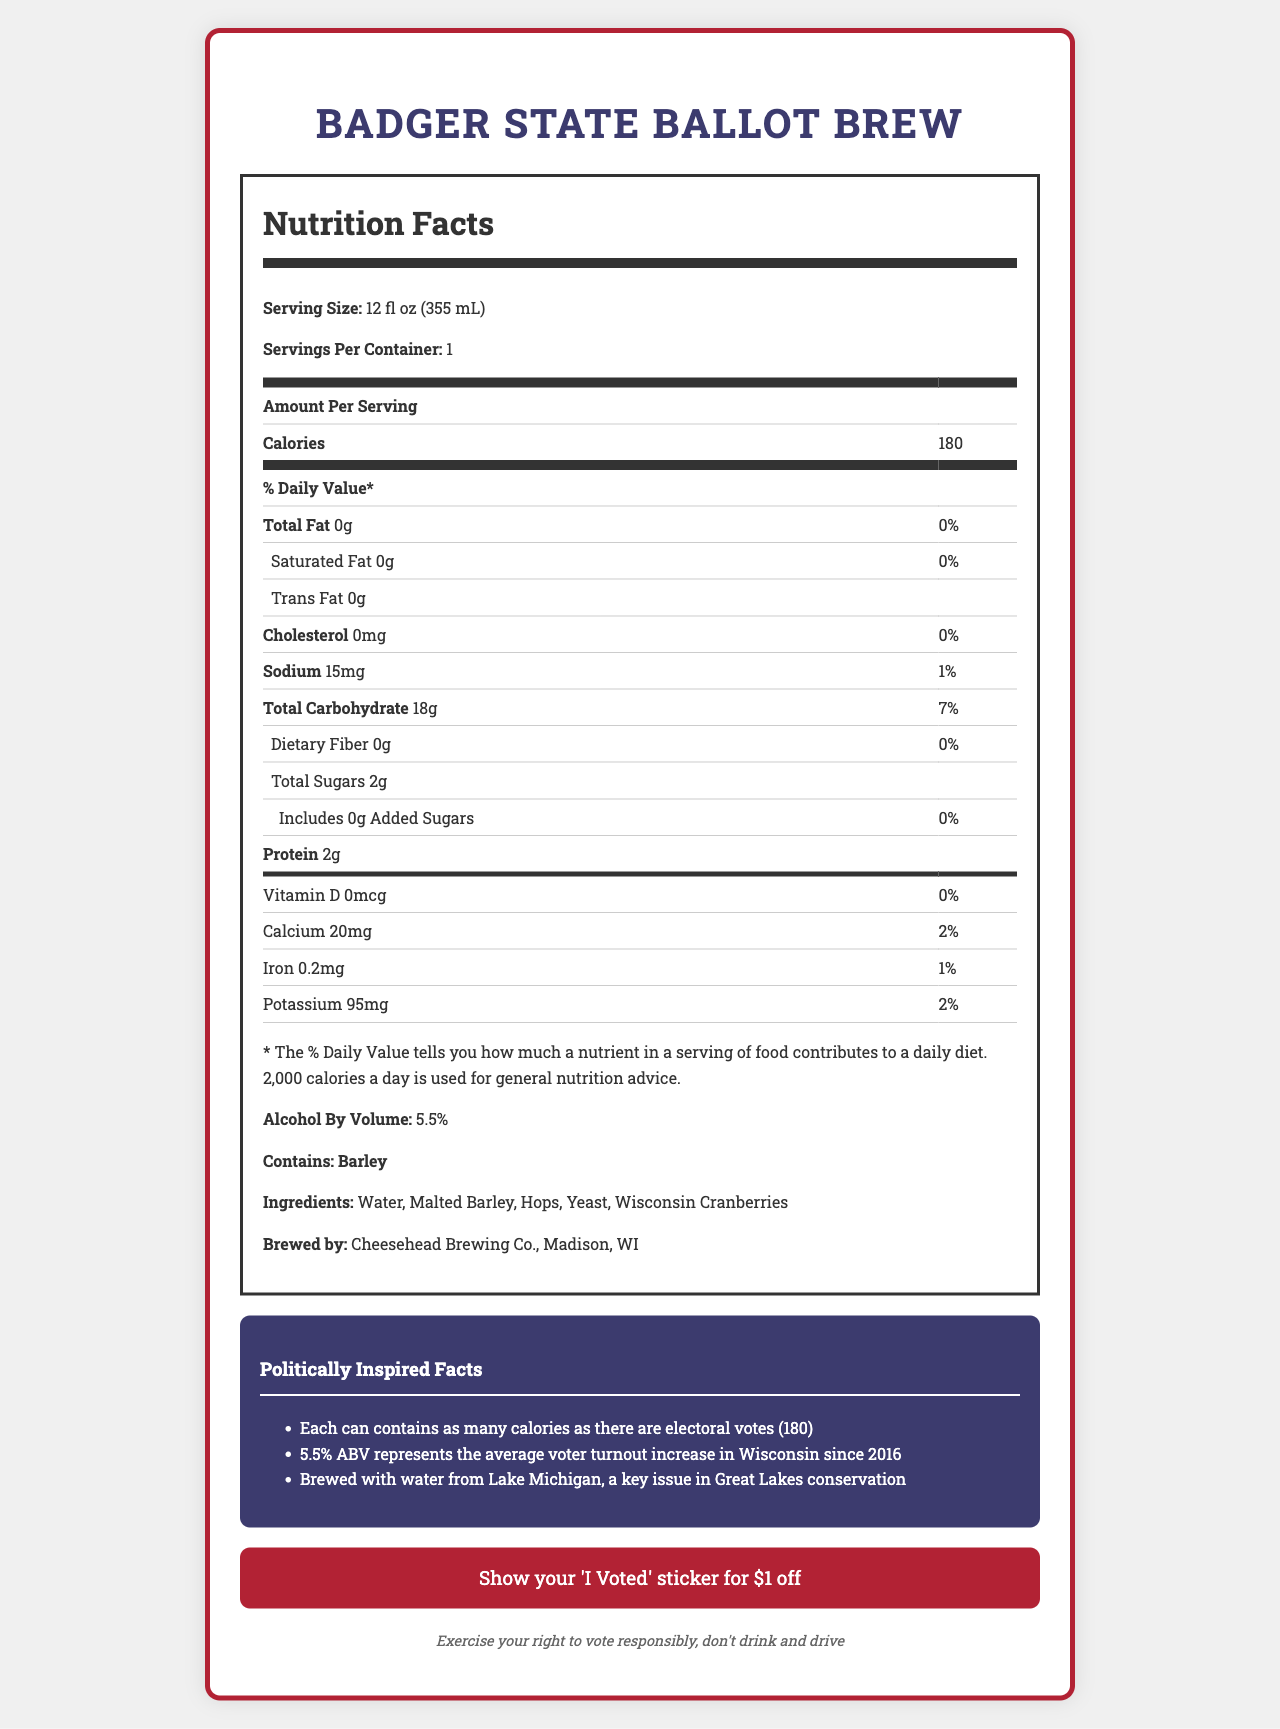what is the serving size of the Badger State Ballot Brew? The serving size is explicitly stated in the nutrition facts section of the document as "Serving Size: 12 fl oz (355 mL)".
Answer: 12 fl oz (355 mL) how many calories are in one serving of the Badger State Ballot Brew? The number of calories per serving is clearly listed as "Calories: 180" in the nutrition facts.
Answer: 180 what is the alcohol by volume (ABV) percentage? The alcohol content is specified in the nutrition facts section as "Alcohol By Volume: 5.5%".
Answer: 5.5% which allergen does the Badger State Ballot Brew contain? The allergen information is particularly shown under the allergens section as "Contains: Barley".
Answer: Barley name three ingredients included in the Badger State Ballot Brew? The ingredient list in the nutrition facts section includes "Water, Malted Barley, Hops, Yeast, Wisconsin Cranberries".
Answer: Water, Malted Barley, Hops what brewery produces the Badger State Ballot Brew? The brewery information is given toward the bottom of the document as "Brewed by: Cheesehead Brewing Co., Madison, WI".
Answer: Cheesehead Brewing Co. what promo is available for election night? The promotional information states: "Show your 'I Voted' sticker for $1 off".
Answer: Show your 'I Voted' sticker for $1 off how is the number of calories connected to the election? One of the politically inspired facts mentioned is that the number of calories corresponds to the number of electoral votes, which is indicated next to the calorie count.
Answer: Each can contains as many calories as there are electoral votes (180) how much potassium does one serving of the Badger State Ballot Brew contain? The potassium content is listed as "Potassium 95mg" in the nutrition facts table.
Answer: 95mg what is the significance of the 5.5% ABV mentioned in the document? A. Percentage of alcohol by volume B. Average voter turnout increase in Wisconsin since 2016 C. Amount of votes cast in the election Among the politically inspired facts, it's stated that "5.5% ABV represents the average voter turnout increase in Wisconsin since 2016".
Answer: B which lake's water is used in brewing the Badger State Ballot Brew? 1. Lake Superior 2. Lake Michigan 3. Lake Huron The document mentions that the beer is brewed with water from Lake Michigan under the politically inspired facts.
Answer: 2 does the Badger State Ballot Brew contain any cholesterol? The nutrition facts state "Cholesterol: 0mg", meaning it contains no cholesterol.
Answer: No summarize the main idea of the Badger State Ballot Brew's nutrition facts document. The document lists calories, macronutrients, and micronutrient breakdown, ingredients, allergen information, and provides special politically inspired facts. It includes a promotion for showing an 'I Voted' sticker and emphasizes responsible drinking.
Answer: The Badger State Ballot Brew's nutrition facts document provides detailed information on the brew's nutritional content, ingredients, and special election-themed promotions and facts, highlighting its low-fat contents and unique tie to local politics. how does the Badger State Ballot Brew compare to other beverages in terms of saturated fat content? The document only provides information for the Badger State Ballot Brew and does not include data for other beverages, so a comparison cannot be made.
Answer: Cannot be determined 